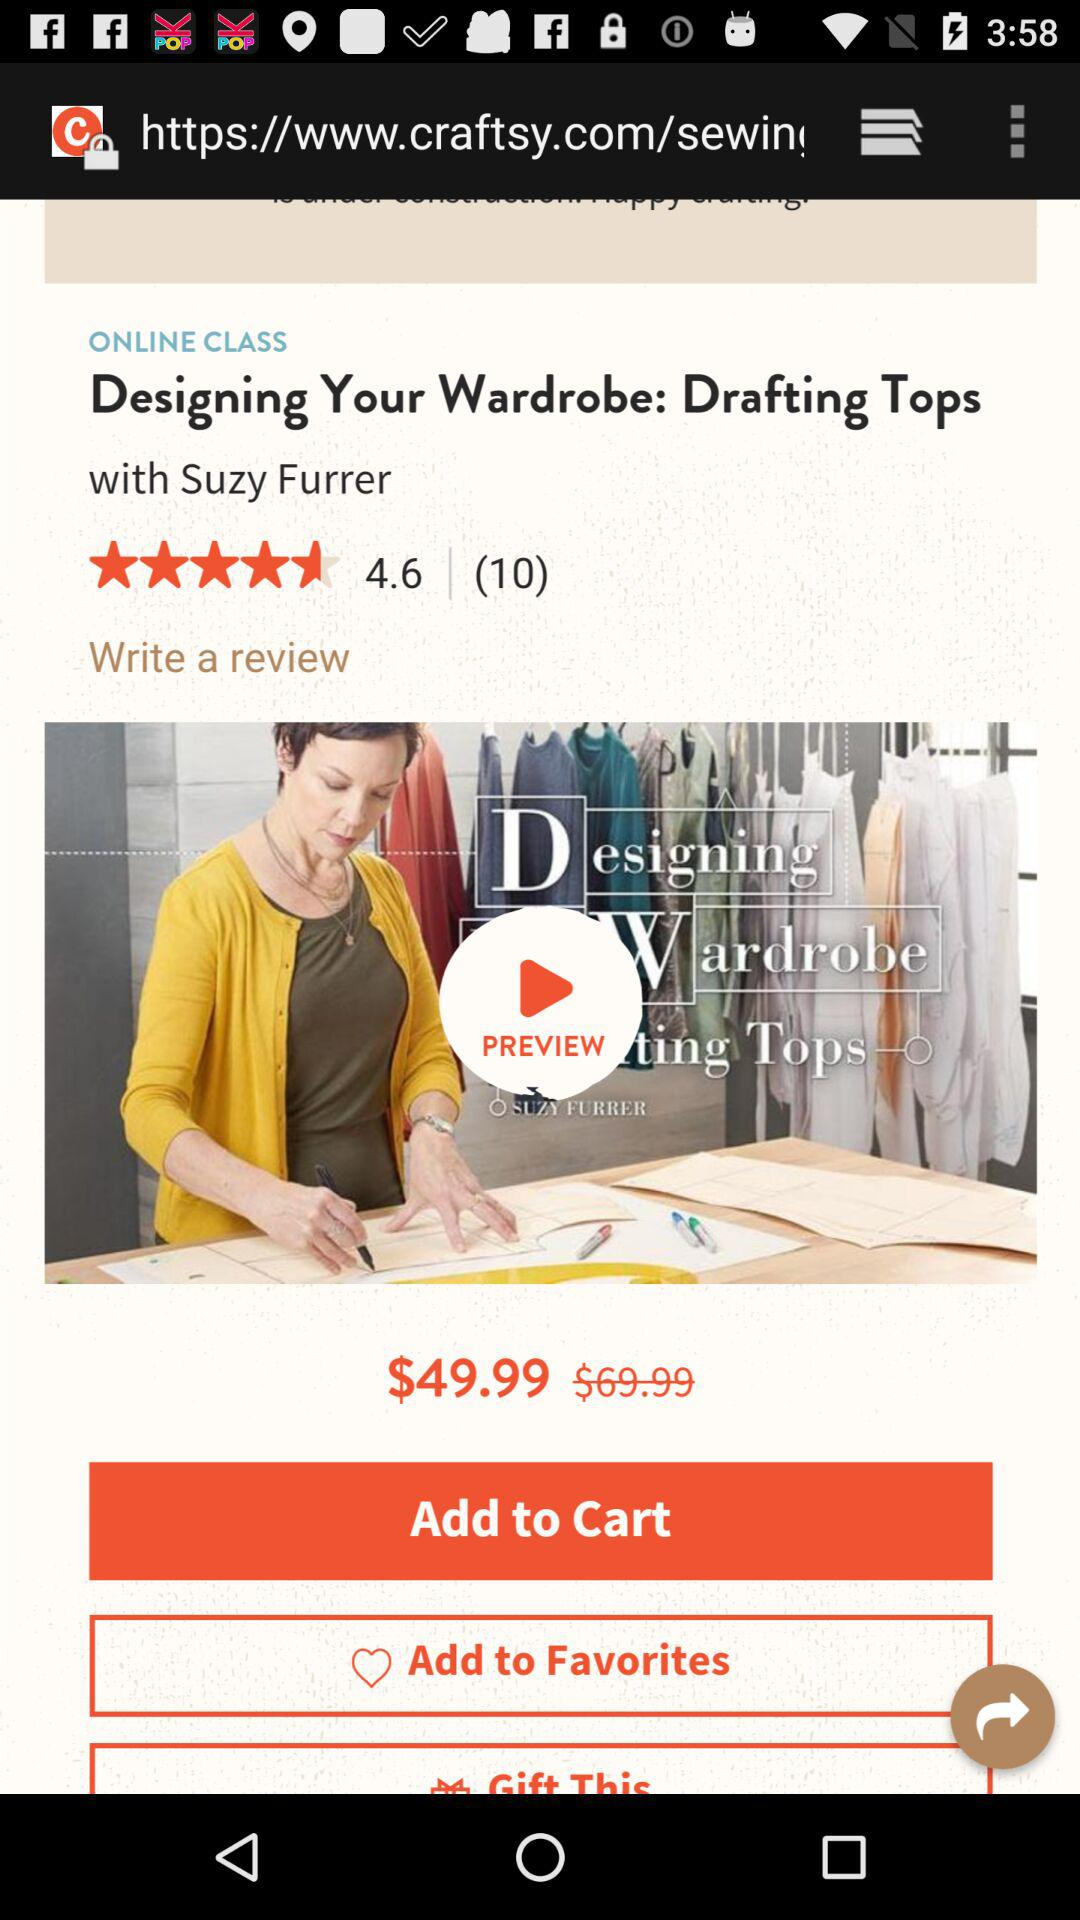What is the cost given? The given cost is $49.99. 